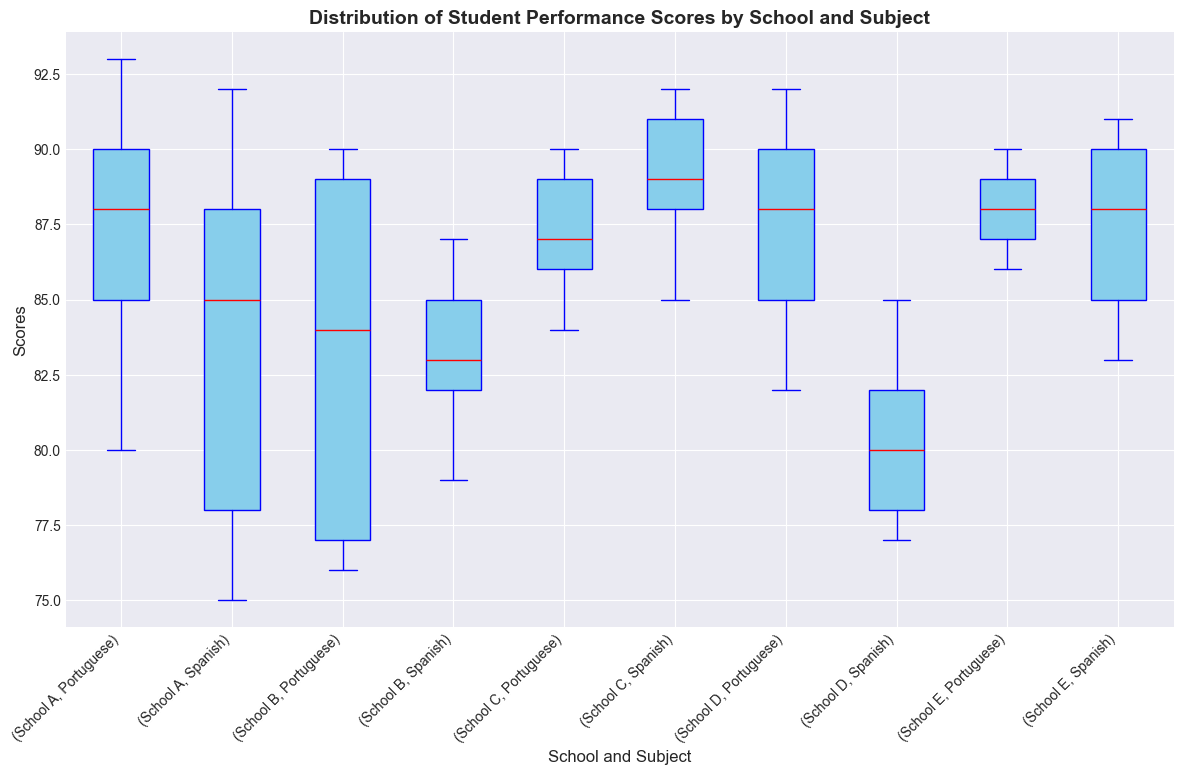What's the median score in Spanish assessments at School A? Locate the box for Spanish at School A and find the line inside the box, which represents the median.
Answer: 85 Which school has the highest median score in Portuguese assessments? Compare the midlines of the boxes for Portuguese scores across all schools. The highest median line identifies the school.
Answer: School A Between Schools B and D, which had the greater variability in Spanish scores? Check the length of the boxes (Interquartile Range) and the whiskers for Spanish scores in Schools B and D. The longer the box and whiskers combined, the greater the variability.
Answer: School D What is the interquartile range (IQR) of Portuguese scores at School C? Find the Portuguese box for School C, and measure the distance between the lower quartile (bottom of the box) and upper quartile (top of the box).
Answer: 3 (89 - 86) Identify the school and subject with the smallest range of scores. Look for the shortest box with whiskers among all the subject and school combinations. Verify the range visually.
Answer: School E, Portuguese Which school has more consistent student performance in Spanish assessments? Determine consistency by finding the school with the smallest box and whiskers in the Spanish sections. Compare the visual lengths.
Answer: School D Did any school have outliers in its assessment scores? Outliers are indicated by individual points outside the whiskers of the boxes. Check all the boxes in the plot for such points.
Answer: No Which subject had the highest median score at School B? Compare the midlines of Spanish and Portuguese boxes at School B. The higher midline marks the subject with the higher median
Answer: Portuguese How do the median Portuguese scores of School A compare to School E? Compare the midlines of the Portuguese boxes of School A and School E to see which is higher.
Answer: School A is higher 